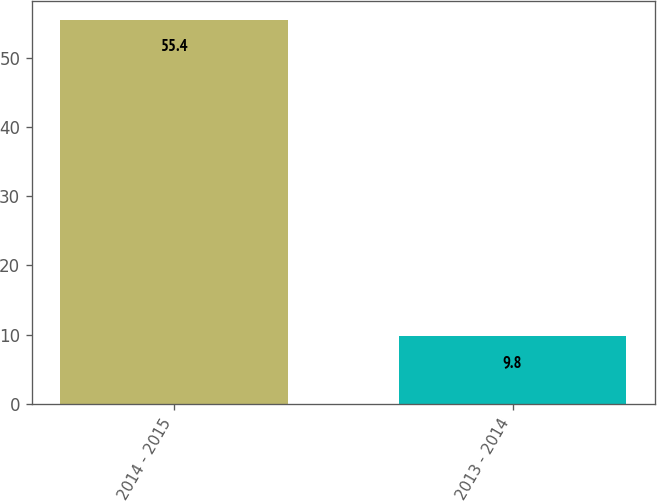Convert chart. <chart><loc_0><loc_0><loc_500><loc_500><bar_chart><fcel>2014 - 2015<fcel>2013 - 2014<nl><fcel>55.4<fcel>9.8<nl></chart> 